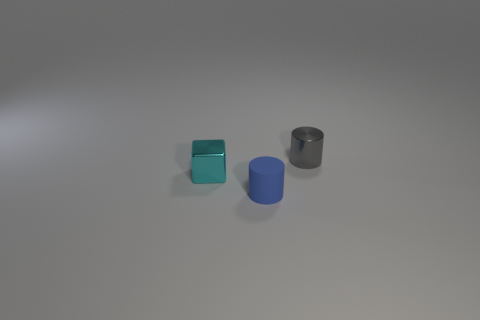Add 2 cyan cubes. How many objects exist? 5 Subtract all cubes. How many objects are left? 2 Add 2 tiny cyan metal cubes. How many tiny cyan metal cubes exist? 3 Subtract 0 red cylinders. How many objects are left? 3 Subtract all big cyan cylinders. Subtract all tiny rubber things. How many objects are left? 2 Add 2 tiny cyan metal cubes. How many tiny cyan metal cubes are left? 3 